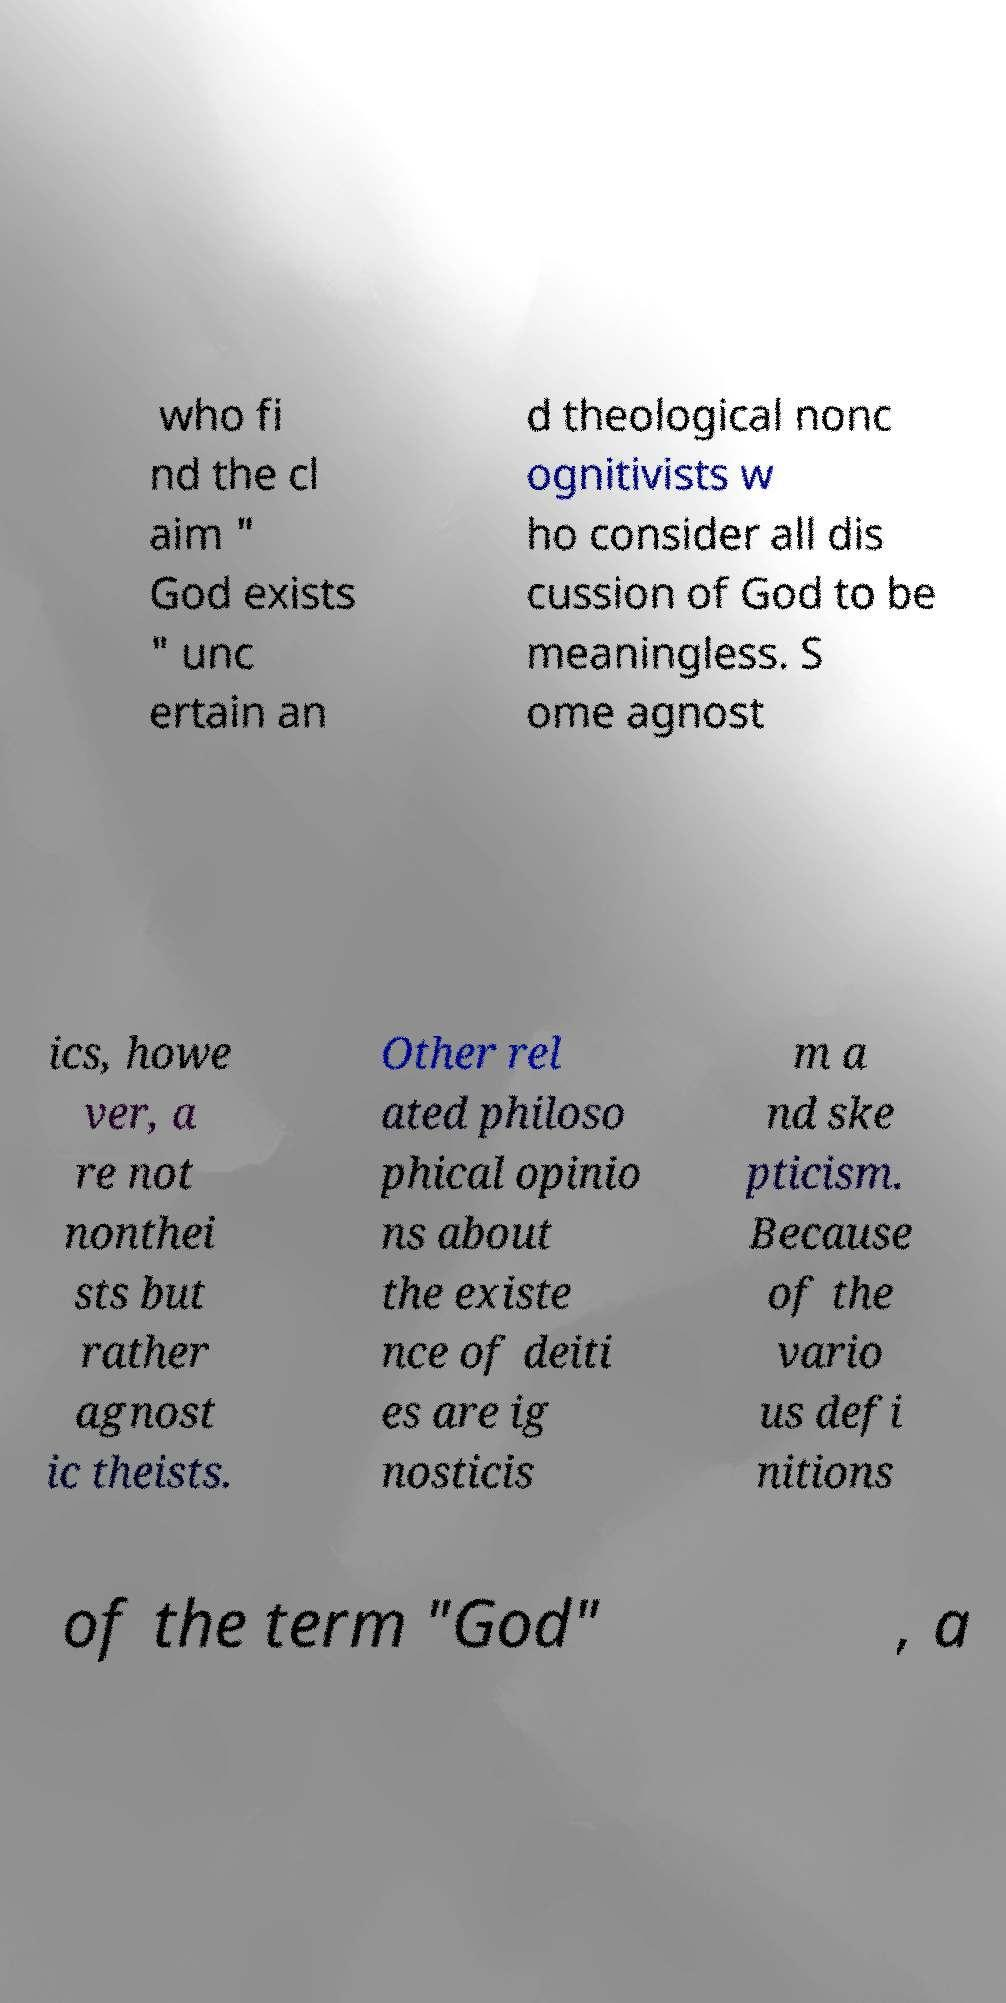Can you accurately transcribe the text from the provided image for me? who fi nd the cl aim " God exists " unc ertain an d theological nonc ognitivists w ho consider all dis cussion of God to be meaningless. S ome agnost ics, howe ver, a re not nonthei sts but rather agnost ic theists. Other rel ated philoso phical opinio ns about the existe nce of deiti es are ig nosticis m a nd ske pticism. Because of the vario us defi nitions of the term "God" , a 